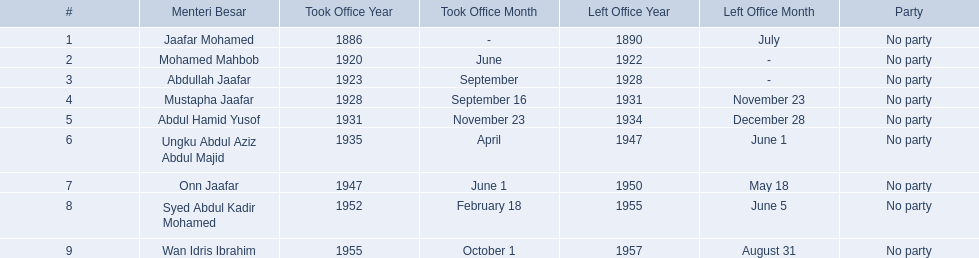Which menteri besars took office in the 1920's? Mohamed Mahbob, Abdullah Jaafar, Mustapha Jaafar. Of those men, who was only in office for 2 years? Mohamed Mahbob. 